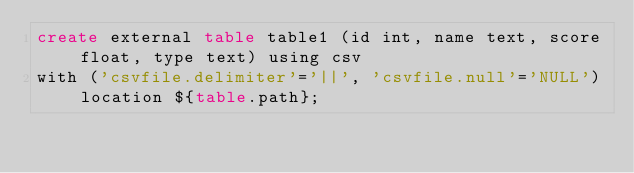<code> <loc_0><loc_0><loc_500><loc_500><_SQL_>create external table table1 (id int, name text, score float, type text) using csv
with ('csvfile.delimiter'='||', 'csvfile.null'='NULL') location ${table.path};

</code> 